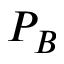<formula> <loc_0><loc_0><loc_500><loc_500>P _ { B }</formula> 